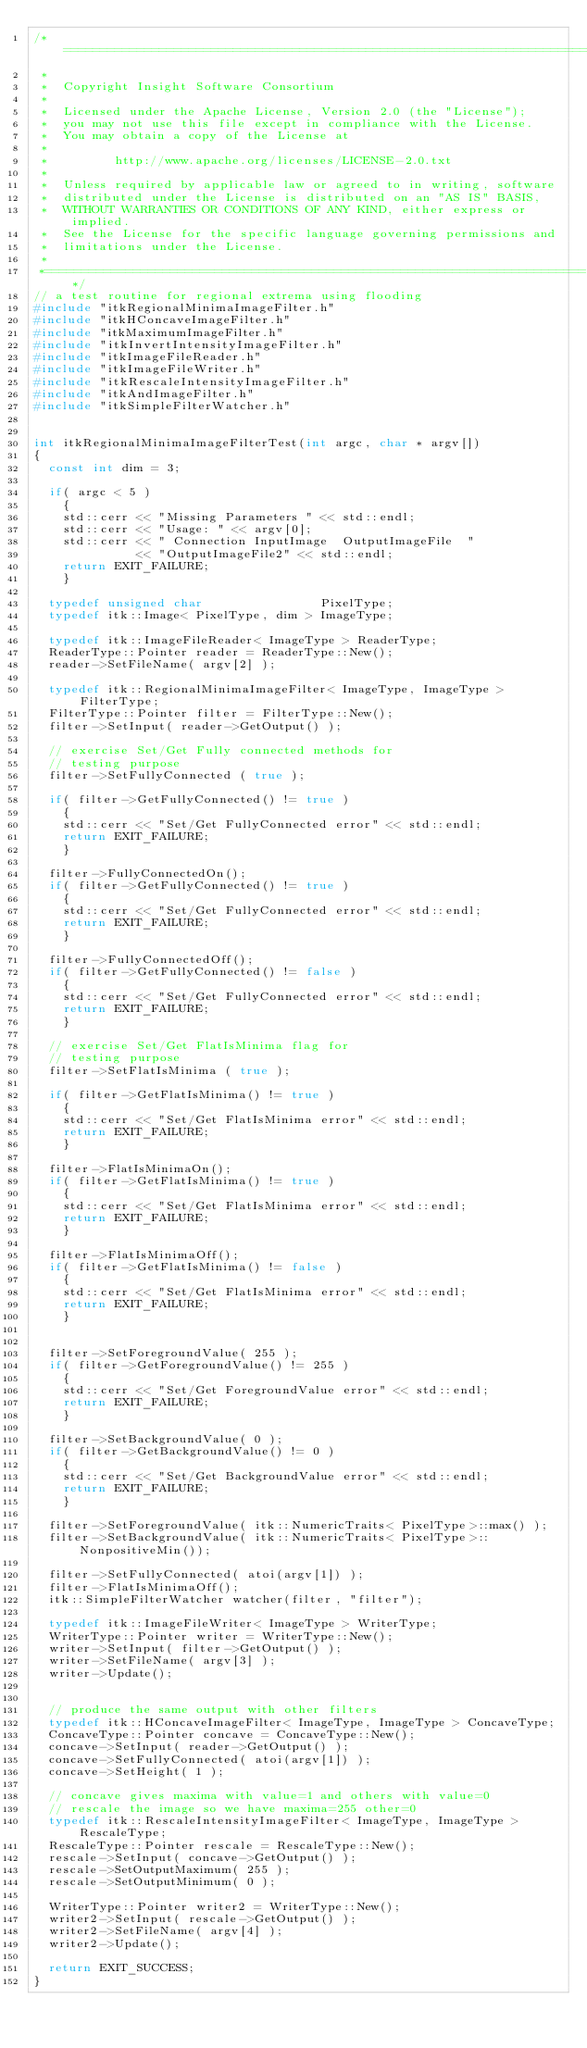Convert code to text. <code><loc_0><loc_0><loc_500><loc_500><_C++_>/*=========================================================================
 *
 *  Copyright Insight Software Consortium
 *
 *  Licensed under the Apache License, Version 2.0 (the "License");
 *  you may not use this file except in compliance with the License.
 *  You may obtain a copy of the License at
 *
 *         http://www.apache.org/licenses/LICENSE-2.0.txt
 *
 *  Unless required by applicable law or agreed to in writing, software
 *  distributed under the License is distributed on an "AS IS" BASIS,
 *  WITHOUT WARRANTIES OR CONDITIONS OF ANY KIND, either express or implied.
 *  See the License for the specific language governing permissions and
 *  limitations under the License.
 *
 *=========================================================================*/
// a test routine for regional extrema using flooding
#include "itkRegionalMinimaImageFilter.h"
#include "itkHConcaveImageFilter.h"
#include "itkMaximumImageFilter.h"
#include "itkInvertIntensityImageFilter.h"
#include "itkImageFileReader.h"
#include "itkImageFileWriter.h"
#include "itkRescaleIntensityImageFilter.h"
#include "itkAndImageFilter.h"
#include "itkSimpleFilterWatcher.h"


int itkRegionalMinimaImageFilterTest(int argc, char * argv[])
{
  const int dim = 3;

  if( argc < 5 )
    {
    std::cerr << "Missing Parameters " << std::endl;
    std::cerr << "Usage: " << argv[0];
    std::cerr << " Connection InputImage  OutputImageFile  "
              << "OutputImageFile2" << std::endl;
    return EXIT_FAILURE;
    }

  typedef unsigned char                PixelType;
  typedef itk::Image< PixelType, dim > ImageType;

  typedef itk::ImageFileReader< ImageType > ReaderType;
  ReaderType::Pointer reader = ReaderType::New();
  reader->SetFileName( argv[2] );

  typedef itk::RegionalMinimaImageFilter< ImageType, ImageType > FilterType;
  FilterType::Pointer filter = FilterType::New();
  filter->SetInput( reader->GetOutput() );

  // exercise Set/Get Fully connected methods for
  // testing purpose
  filter->SetFullyConnected ( true );

  if( filter->GetFullyConnected() != true )
    {
    std::cerr << "Set/Get FullyConnected error" << std::endl;
    return EXIT_FAILURE;
    }

  filter->FullyConnectedOn();
  if( filter->GetFullyConnected() != true )
    {
    std::cerr << "Set/Get FullyConnected error" << std::endl;
    return EXIT_FAILURE;
    }

  filter->FullyConnectedOff();
  if( filter->GetFullyConnected() != false )
    {
    std::cerr << "Set/Get FullyConnected error" << std::endl;
    return EXIT_FAILURE;
    }

  // exercise Set/Get FlatIsMinima flag for
  // testing purpose
  filter->SetFlatIsMinima ( true );

  if( filter->GetFlatIsMinima() != true )
    {
    std::cerr << "Set/Get FlatIsMinima error" << std::endl;
    return EXIT_FAILURE;
    }

  filter->FlatIsMinimaOn();
  if( filter->GetFlatIsMinima() != true )
    {
    std::cerr << "Set/Get FlatIsMinima error" << std::endl;
    return EXIT_FAILURE;
    }

  filter->FlatIsMinimaOff();
  if( filter->GetFlatIsMinima() != false )
    {
    std::cerr << "Set/Get FlatIsMinima error" << std::endl;
    return EXIT_FAILURE;
    }


  filter->SetForegroundValue( 255 );
  if( filter->GetForegroundValue() != 255 )
    {
    std::cerr << "Set/Get ForegroundValue error" << std::endl;
    return EXIT_FAILURE;
    }

  filter->SetBackgroundValue( 0 );
  if( filter->GetBackgroundValue() != 0 )
    {
    std::cerr << "Set/Get BackgroundValue error" << std::endl;
    return EXIT_FAILURE;
    }

  filter->SetForegroundValue( itk::NumericTraits< PixelType>::max() );
  filter->SetBackgroundValue( itk::NumericTraits< PixelType>::NonpositiveMin());

  filter->SetFullyConnected( atoi(argv[1]) );
  filter->FlatIsMinimaOff();
  itk::SimpleFilterWatcher watcher(filter, "filter");

  typedef itk::ImageFileWriter< ImageType > WriterType;
  WriterType::Pointer writer = WriterType::New();
  writer->SetInput( filter->GetOutput() );
  writer->SetFileName( argv[3] );
  writer->Update();


  // produce the same output with other filters
  typedef itk::HConcaveImageFilter< ImageType, ImageType > ConcaveType;
  ConcaveType::Pointer concave = ConcaveType::New();
  concave->SetInput( reader->GetOutput() );
  concave->SetFullyConnected( atoi(argv[1]) );
  concave->SetHeight( 1 );

  // concave gives maxima with value=1 and others with value=0
  // rescale the image so we have maxima=255 other=0
  typedef itk::RescaleIntensityImageFilter< ImageType, ImageType > RescaleType;
  RescaleType::Pointer rescale = RescaleType::New();
  rescale->SetInput( concave->GetOutput() );
  rescale->SetOutputMaximum( 255 );
  rescale->SetOutputMinimum( 0 );

  WriterType::Pointer writer2 = WriterType::New();
  writer2->SetInput( rescale->GetOutput() );
  writer2->SetFileName( argv[4] );
  writer2->Update();

  return EXIT_SUCCESS;
}
</code> 